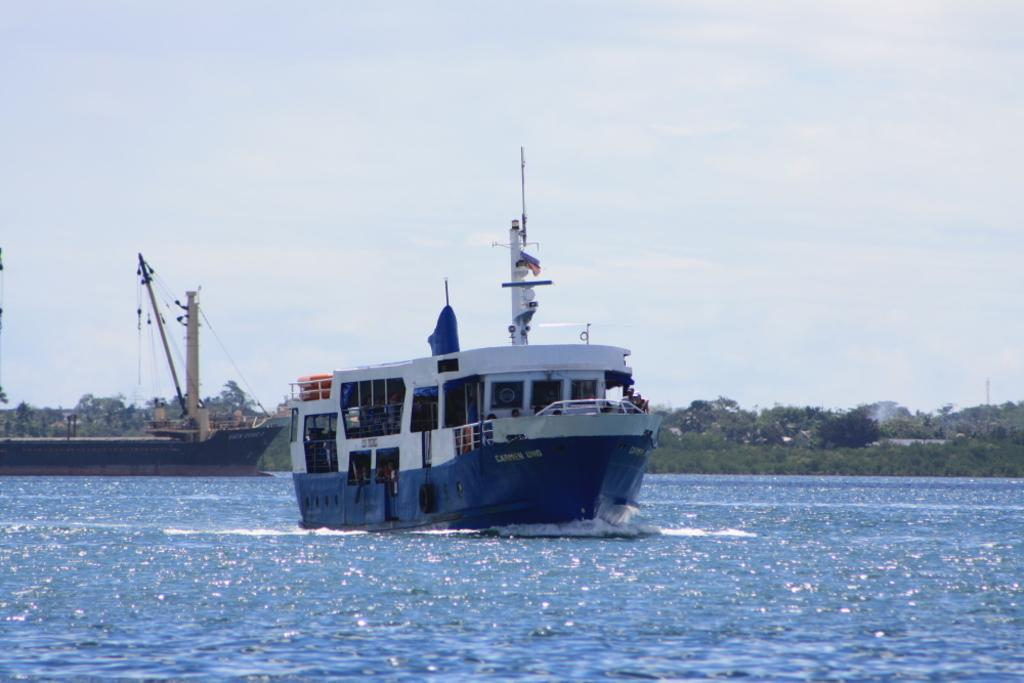What is: What is the main subject of the image? There is a ship in the image. Where is the ship located? The ship is on the water. What colors are used on the ship? The ship has blue and white colors. What can be seen in the background of the image? There are poles and trees with green color in the background of the image. What is the color of the sky in the image? The sky is white in color. What type of force can be seen pushing the ship in the image? There is no force pushing the ship visible in the image; it is stationary on the water. Can you hear a whistle in the image? There is no sound, including a whistle, present in the image. 